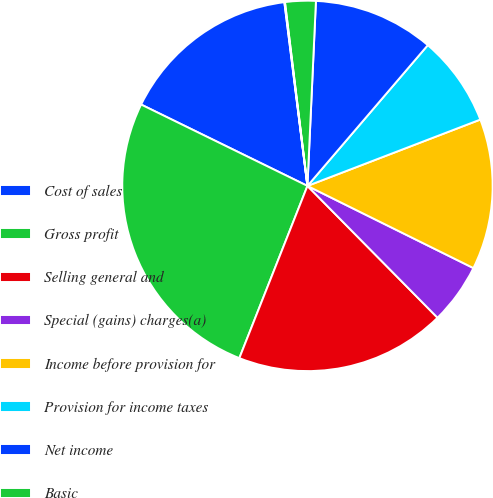Convert chart to OTSL. <chart><loc_0><loc_0><loc_500><loc_500><pie_chart><fcel>Cost of sales<fcel>Gross profit<fcel>Selling general and<fcel>Special (gains) charges(a)<fcel>Income before provision for<fcel>Provision for income taxes<fcel>Net income<fcel>Basic<fcel>Diluted<nl><fcel>15.77%<fcel>26.25%<fcel>18.39%<fcel>5.29%<fcel>13.15%<fcel>7.91%<fcel>10.53%<fcel>2.67%<fcel>0.05%<nl></chart> 